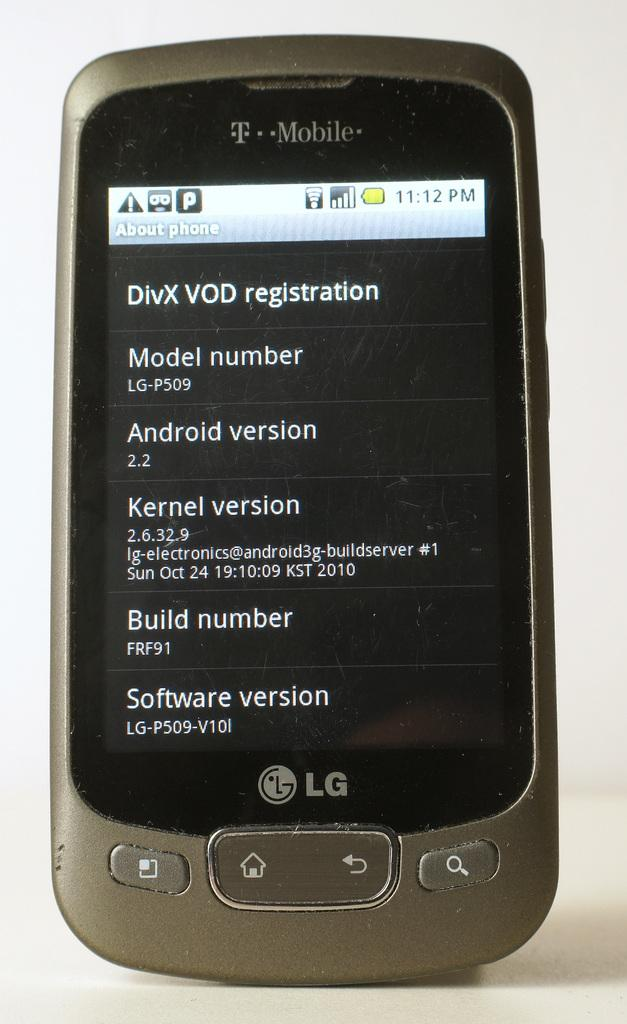<image>
Give a short and clear explanation of the subsequent image. An LG phone with T Mobile service has an active screen. 